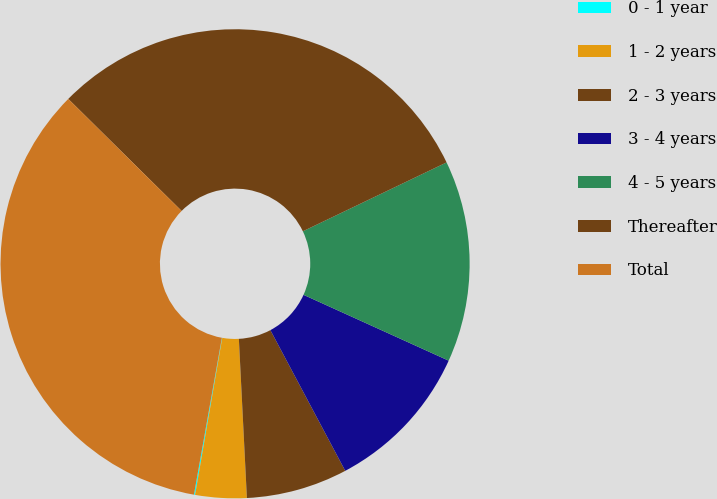<chart> <loc_0><loc_0><loc_500><loc_500><pie_chart><fcel>0 - 1 year<fcel>1 - 2 years<fcel>2 - 3 years<fcel>3 - 4 years<fcel>4 - 5 years<fcel>Thereafter<fcel>Total<nl><fcel>0.08%<fcel>3.53%<fcel>6.98%<fcel>10.44%<fcel>13.89%<fcel>30.48%<fcel>34.6%<nl></chart> 